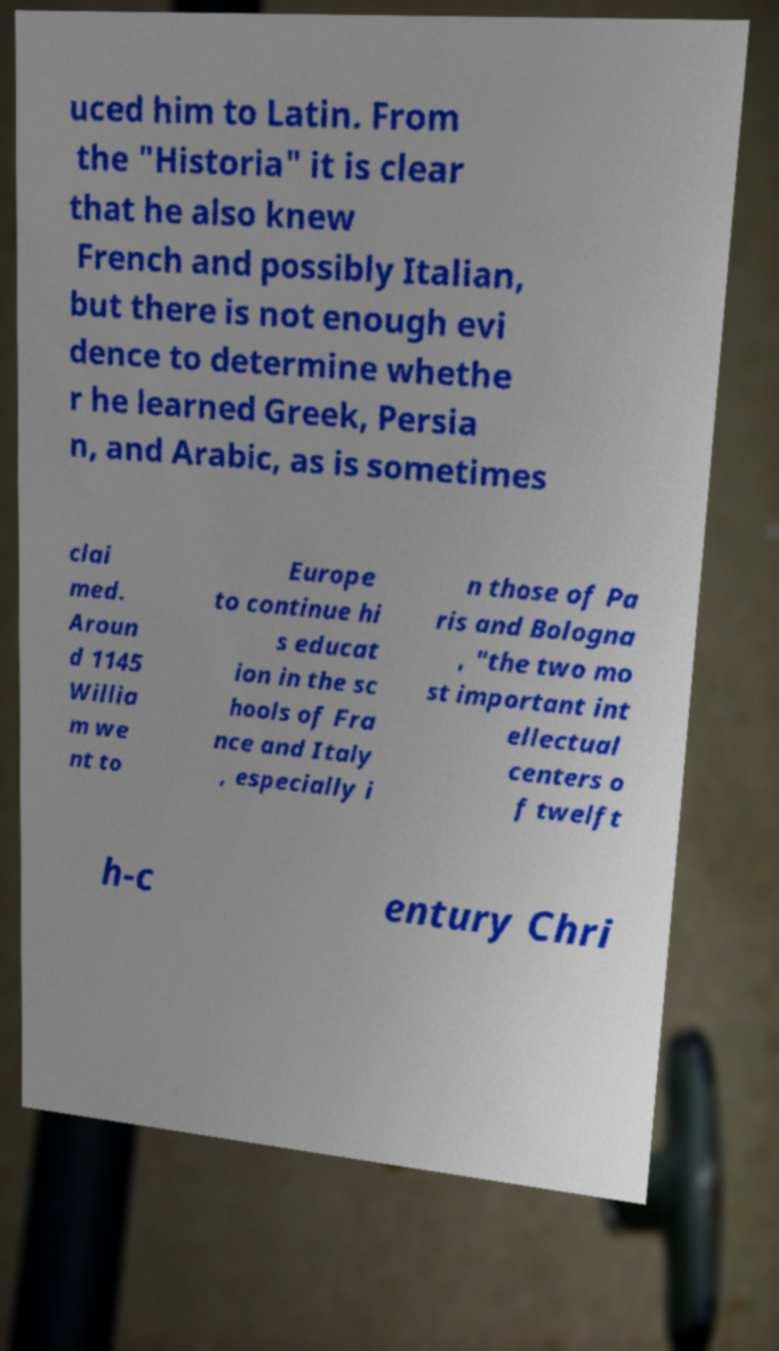Can you read and provide the text displayed in the image?This photo seems to have some interesting text. Can you extract and type it out for me? uced him to Latin. From the "Historia" it is clear that he also knew French and possibly Italian, but there is not enough evi dence to determine whethe r he learned Greek, Persia n, and Arabic, as is sometimes clai med. Aroun d 1145 Willia m we nt to Europe to continue hi s educat ion in the sc hools of Fra nce and Italy , especially i n those of Pa ris and Bologna , "the two mo st important int ellectual centers o f twelft h-c entury Chri 